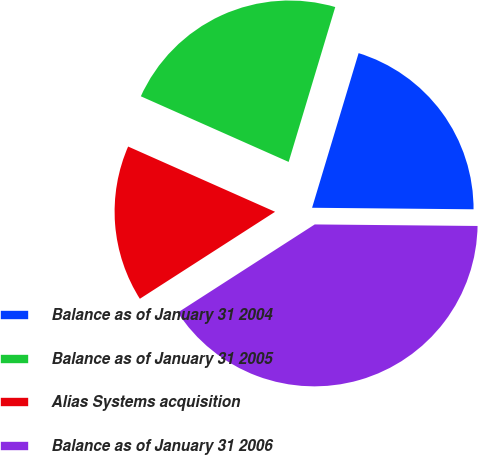Convert chart to OTSL. <chart><loc_0><loc_0><loc_500><loc_500><pie_chart><fcel>Balance as of January 31 2004<fcel>Balance as of January 31 2005<fcel>Alias Systems acquisition<fcel>Balance as of January 31 2006<nl><fcel>20.5%<fcel>23.0%<fcel>15.75%<fcel>40.75%<nl></chart> 